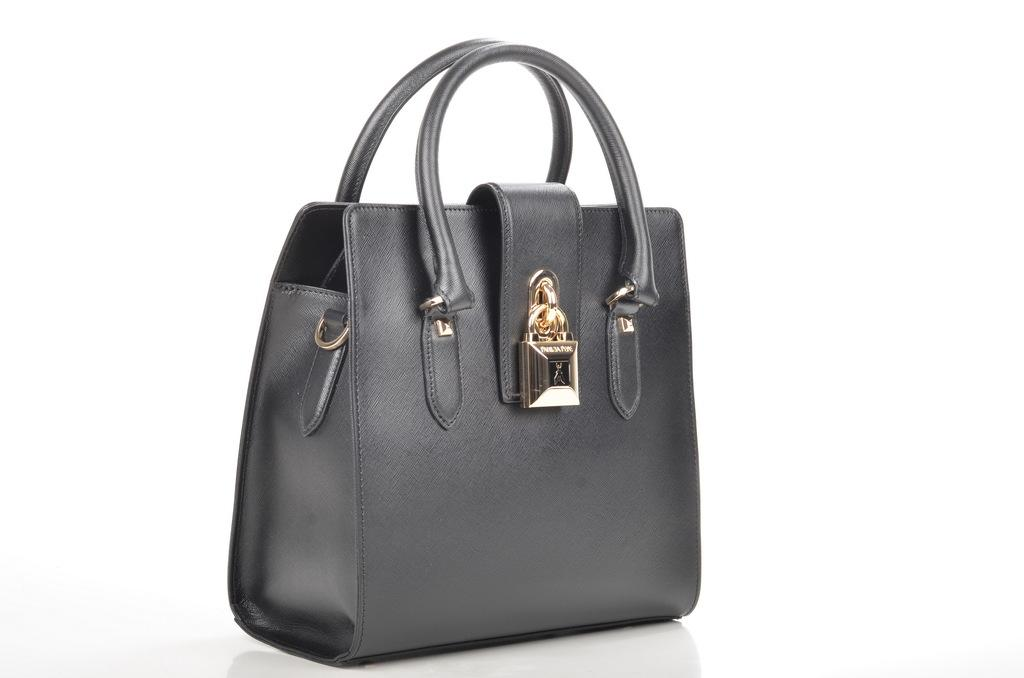What type of accessory is present in the image? There is a handbag in the picture. What material is the handbag made of? The handbag is made of leather. Does the handbag have any additional features? Yes, the handbag has a holder. How is the holder decorated? The holder is painted as a golden decorative object. Reasoning: Let' Let's think step by step in order to produce the conversation. We start by identifying the main subject in the image, which is the handbag. Then, we describe the material it is made of, which is leather. Next, we mention the presence of a holder and its decorative nature, which is painted as a golden object. Each question is designed to elicit a specific detail about the image that is known from the provided facts. Absurd Question/Answer: What is the handbag's desire to move in a circle in the image? The handbag does not have desires, as it is an inanimate object. Additionally, there is no indication of movement or circles in the image. 